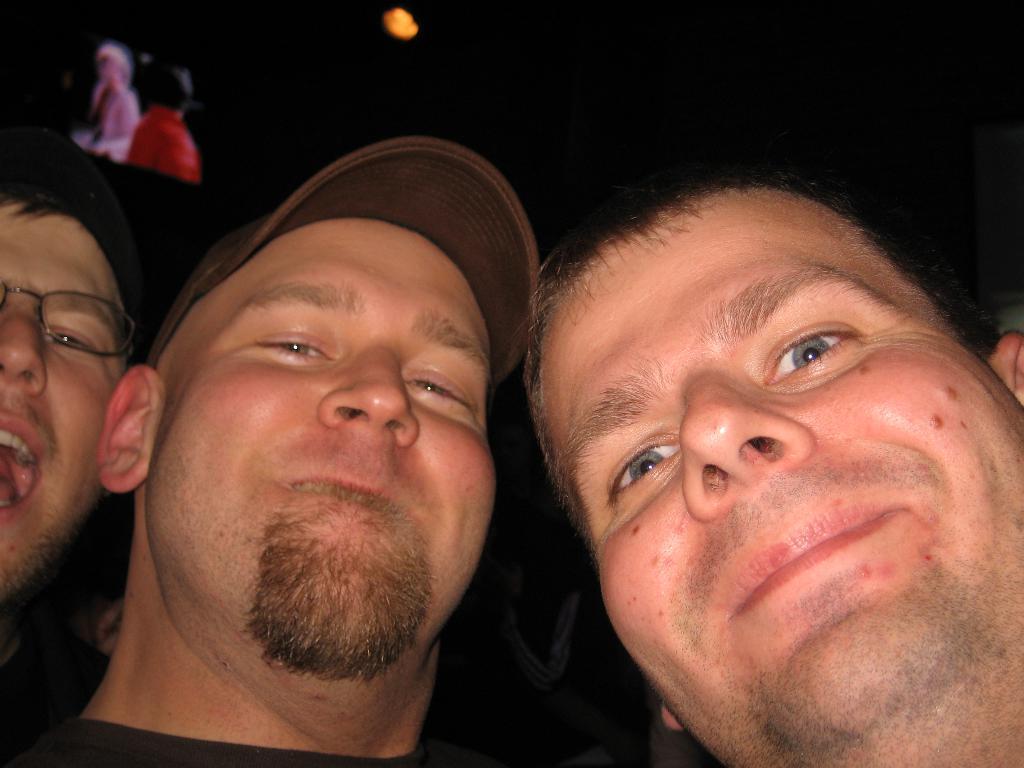Could you give a brief overview of what you see in this image? In the image there are three men beside each other smiling and on the left side there is a screen and a light over the ceiling. 